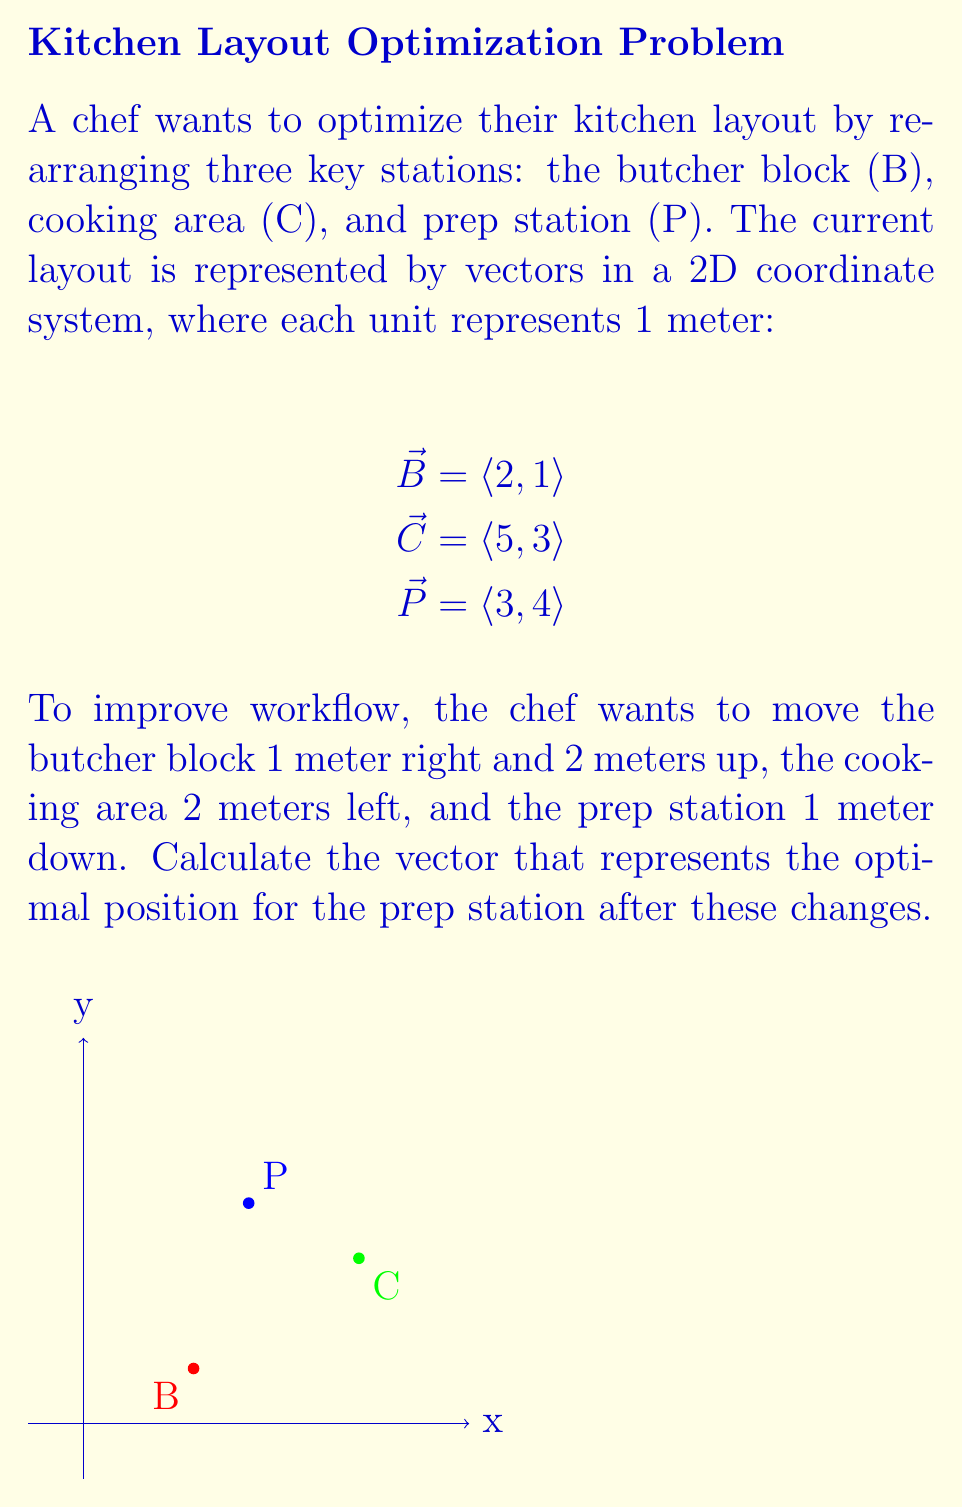Teach me how to tackle this problem. Let's approach this step-by-step:

1) First, we need to create vectors for the movements:
   - Butcher block: $\vec{B_{move}} = \langle 1, 2 \rangle$
   - Cooking area: $\vec{C_{move}} = \langle -2, 0 \rangle$
   - Prep station: $\vec{P_{move}} = \langle 0, -1 \rangle$

2) Now, we add these movement vectors to the original position vectors:

   For the butcher block:
   $\vec{B_{new}} = \vec{B} + \vec{B_{move}} = \langle 2, 1 \rangle + \langle 1, 2 \rangle = \langle 3, 3 \rangle$

   For the cooking area:
   $\vec{C_{new}} = \vec{C} + \vec{C_{move}} = \langle 5, 3 \rangle + \langle -2, 0 \rangle = \langle 3, 3 \rangle$

   For the prep station:
   $\vec{P_{new}} = \vec{P} + \vec{P_{move}} = \langle 3, 4 \rangle + \langle 0, -1 \rangle = \langle 3, 3 \rangle$

3) The question asks for the optimal position of the prep station, which we've just calculated as $\vec{P_{new}} = \langle 3, 3 \rangle$.
Answer: $\langle 3, 3 \rangle$ 